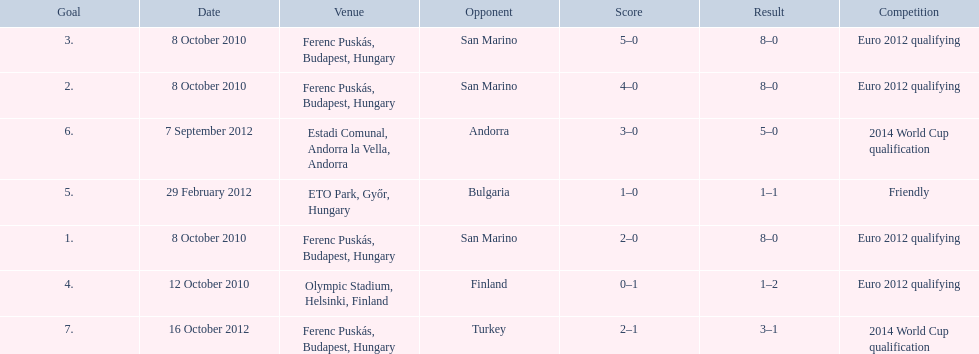When did ádám szalai make his first international goal? 8 October 2010. 